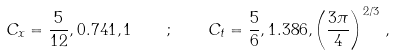<formula> <loc_0><loc_0><loc_500><loc_500>C _ { x } = \frac { 5 } { 1 2 } , 0 . 7 4 1 , 1 \quad ; \quad C _ { t } = \frac { 5 } { 6 } , 1 . 3 8 6 , \left ( \frac { 3 \pi } { 4 } \right ) ^ { 2 / 3 } \, ,</formula> 